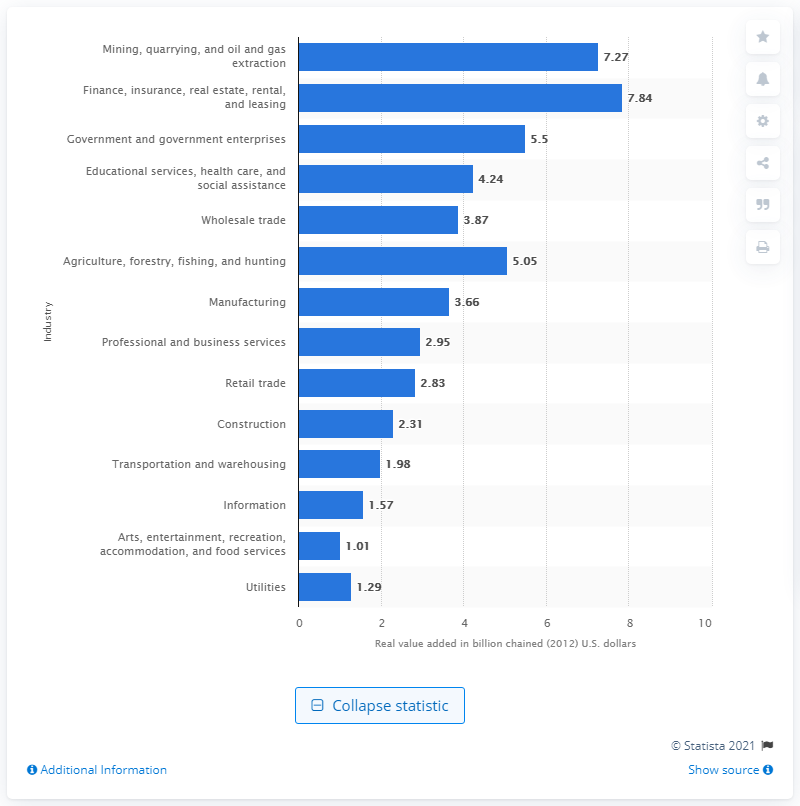Specify some key components in this picture. In 2012, the mining, quarrying, and oil and gas extraction industry added 7.27 billion dollars to the Gross Domestic Product (GDP) of North Dakota. 